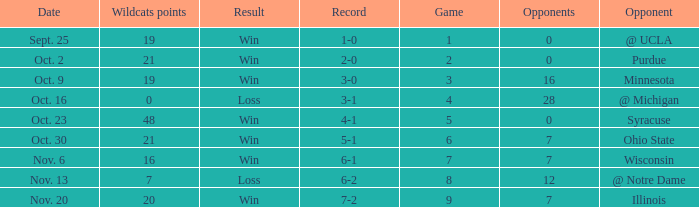Could you parse the entire table as a dict? {'header': ['Date', 'Wildcats points', 'Result', 'Record', 'Game', 'Opponents', 'Opponent'], 'rows': [['Sept. 25', '19', 'Win', '1-0', '1', '0', '@ UCLA'], ['Oct. 2', '21', 'Win', '2-0', '2', '0', 'Purdue'], ['Oct. 9', '19', 'Win', '3-0', '3', '16', 'Minnesota'], ['Oct. 16', '0', 'Loss', '3-1', '4', '28', '@ Michigan'], ['Oct. 23', '48', 'Win', '4-1', '5', '0', 'Syracuse'], ['Oct. 30', '21', 'Win', '5-1', '6', '7', 'Ohio State'], ['Nov. 6', '16', 'Win', '6-1', '7', '7', 'Wisconsin'], ['Nov. 13', '7', 'Loss', '6-2', '8', '12', '@ Notre Dame'], ['Nov. 20', '20', 'Win', '7-2', '9', '7', 'Illinois']]} How many wins or losses were there when the record was 3-0? 1.0. 